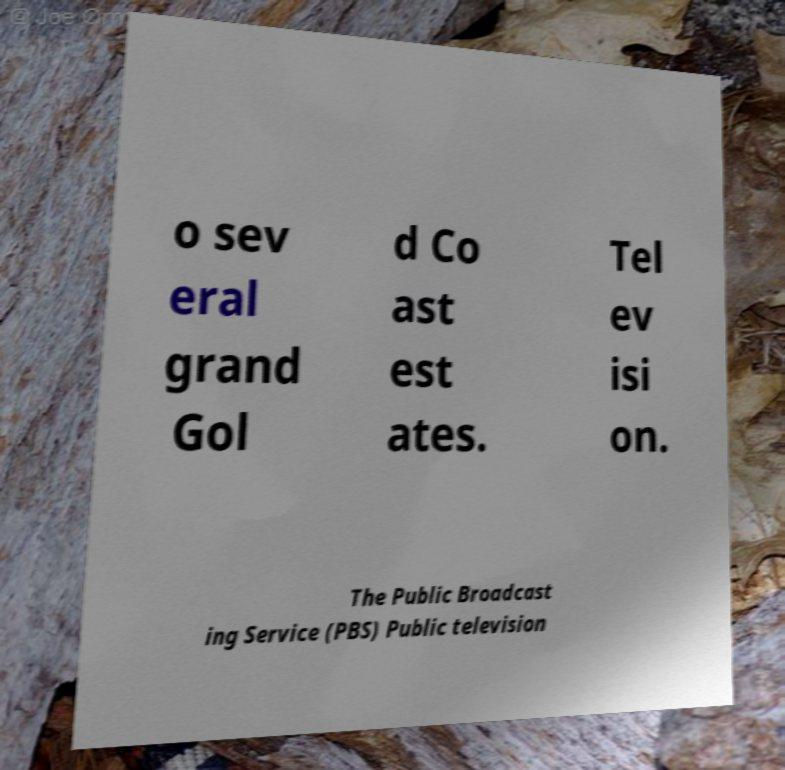I need the written content from this picture converted into text. Can you do that? o sev eral grand Gol d Co ast est ates. Tel ev isi on. The Public Broadcast ing Service (PBS) Public television 